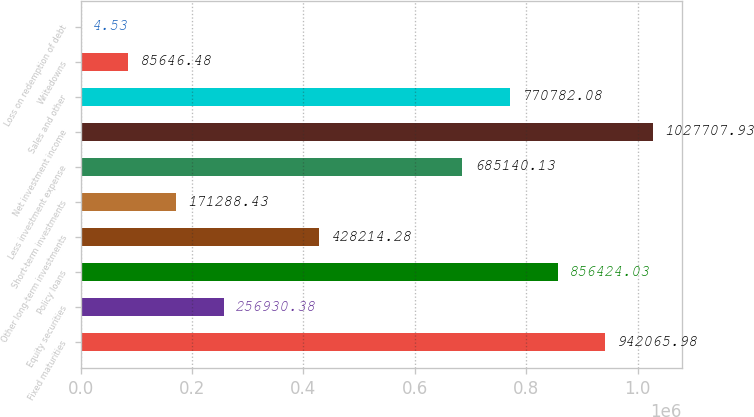<chart> <loc_0><loc_0><loc_500><loc_500><bar_chart><fcel>Fixed maturities<fcel>Equity securities<fcel>Policy loans<fcel>Other long-term investments<fcel>Short-term investments<fcel>Less investment expense<fcel>Net investment income<fcel>Sales and other<fcel>Writedowns<fcel>Loss on redemption of debt<nl><fcel>942066<fcel>256930<fcel>856424<fcel>428214<fcel>171288<fcel>685140<fcel>1.02771e+06<fcel>770782<fcel>85646.5<fcel>4.53<nl></chart> 